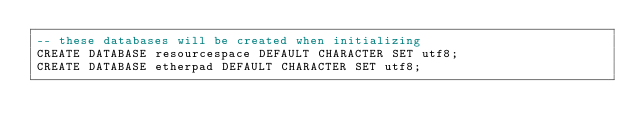<code> <loc_0><loc_0><loc_500><loc_500><_SQL_>-- these databases will be created when initializing
CREATE DATABASE resourcespace DEFAULT CHARACTER SET utf8;
CREATE DATABASE etherpad DEFAULT CHARACTER SET utf8;</code> 